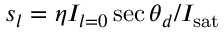<formula> <loc_0><loc_0><loc_500><loc_500>s _ { l } = \eta I _ { l = 0 } \sec \theta _ { d } / I _ { s a t }</formula> 